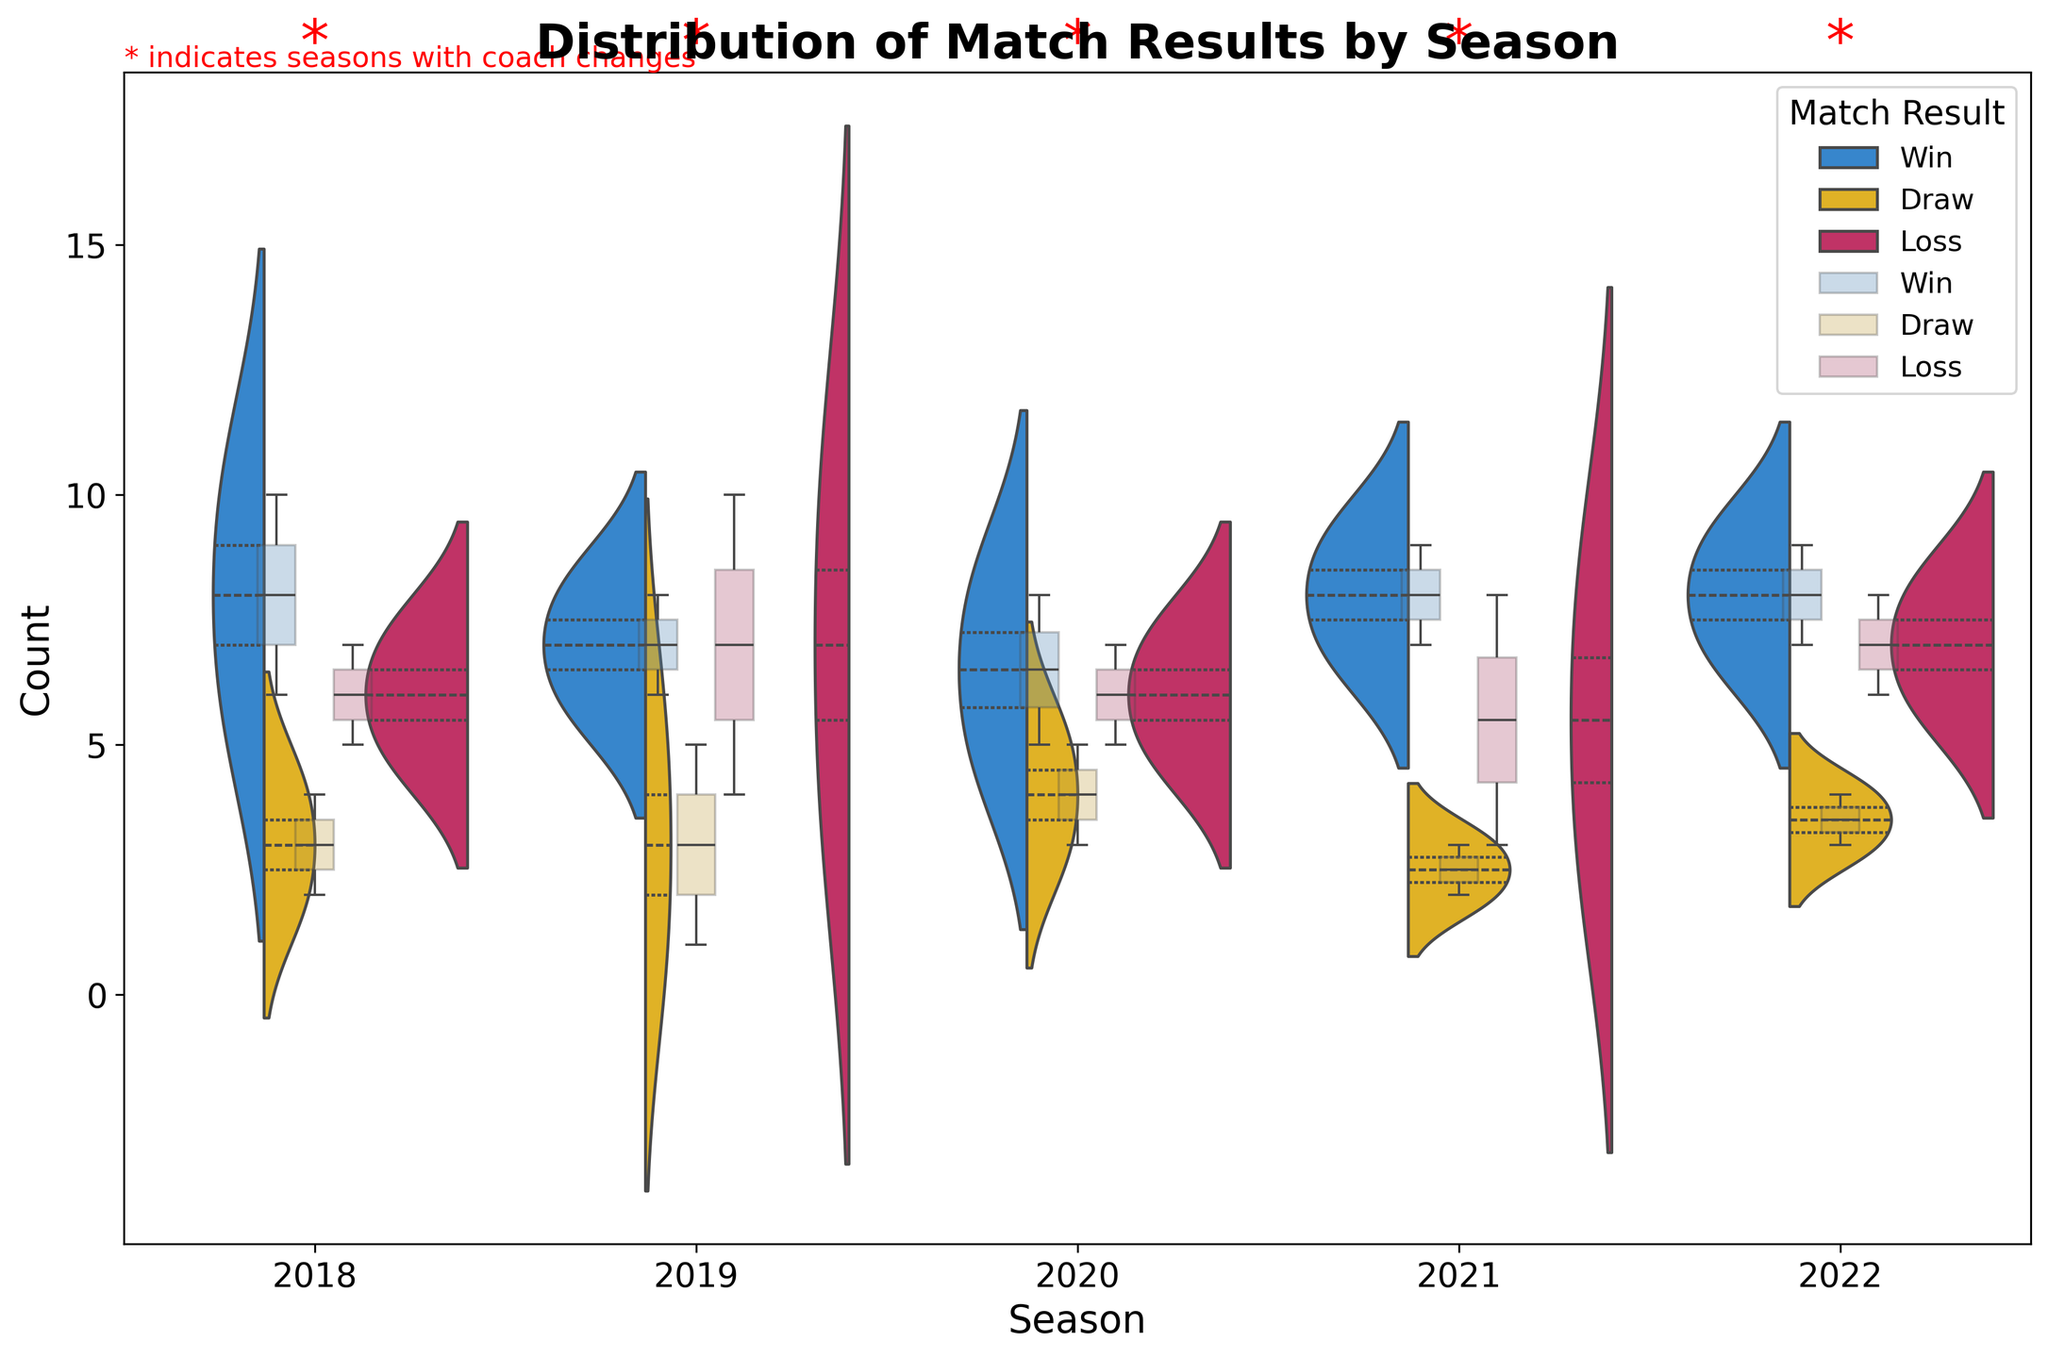What is the title of the plot? The title is usually located at the top of the plot. It provides an overview of what the plot is about.
Answer: Distribution of Match Results by Season Which seasons had coach changes? Coach changes are indicated by red asterisks '*' above the associated season's plot.
Answer: 2018, 2019, 2020, 2021, 2022 What is the highest count of wins in a single season, and in which season did it occur? Look for the tallest section within the violin for 'Win' in each season and identify the maximum. 2021 has the highest count of wins, reaching 9.
Answer: 9, 2021 How do the distributions of draws in 2018 compare to 2019? Observe the width and shape of the violin plot for 'Draw' in the seasons 2018 and 2019. The distribution of draws in 2019 appears to have a slightly higher count but a similar spread compared to 2018.
Answer: Higher in 2019, similar spread Are there more losses in 2018 or 2019, and by how much? Compare the violin plots for 'Loss' in 2018 and 2019 and calculate the difference in counts. 2018 has 12 losses and 2019 has 14 losses, so 2019 has 2 more losses.
Answer: 2019 by 2 Which match outcome has the most frequent occurrence in 2022? Look for the outcome (Win, Draw, Loss) with the greatest count in the 2022 season. 'Win' has the most frequent occurrence with a count of 9.
Answer: Win What is the median count of losses in 2020? Examine the box plot overlay within the violin plot for 'Loss' in 2020 and find the median indicated by a horizontal line inside the box. The median count of losses in 2020 is 6.
Answer: 6 How does the distribution of wins differ between 2021 and 2022? Compare the shapes and widths of the violin plots for 'Win' in 2021 and 2022. The distribution of wins in 2021 is more spread out and has a higher median compared to 2022, which has a more compact distribution.
Answer: More spread out in 2021, higher median Is there a noticeable trend in the number of draws over the seasons? Observe the violin plots for 'Draw' across all seasons to see if there's an increasing or decreasing pattern. The number of draws fluctuates but does not show a clear increasing or decreasing trend.
Answer: No clear trend 